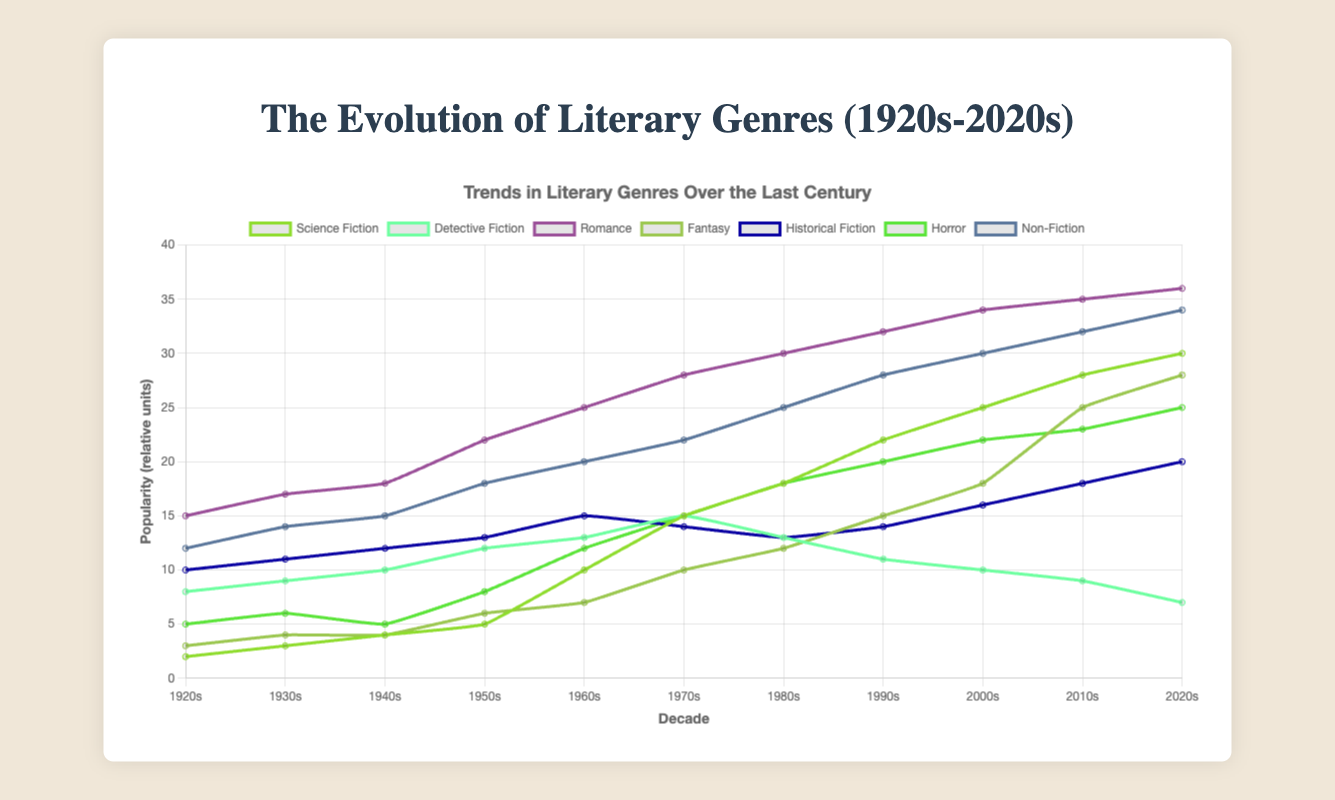Which genre shows the highest increase in popularity from the 1920s to the 2020s? To find out which genre shows the highest increase in popularity from the 1920s to the 2020s, we need to look at the difference in popularity scores between these two decades for each genre. The differences are: Science Fiction (30-2=28), Detective Fiction (7-8=-1), Romance (36-15=21), Fantasy (28-3=25), Historical Fiction (20-10=10), Horror (25-5=20), Non-Fiction (34-12=22). Therefore, Science Fiction shows the highest increase with a change of 28.
Answer: Science Fiction Which genre experienced a decline in popularity from the 1950s to the 2020s? To determine which genre experienced a decline in popularity from the 1950s to the 2020s, we need to compare the popularity scores in these two decades: Science Fiction (5 to 30), Detective Fiction (12 to 7), Romance (22 to 36), Fantasy (6 to 28), Historical Fiction (13 to 20), Horror (8 to 25), Non-Fiction (18 to 34). The only genre with a decline is Detective Fiction, which decreases from 12 to 7.
Answer: Detective Fiction What is the average popularity of the Romance genre from the 1920s to the 2020s? We calculate the average popularity of the Romance genre by summing its values and dividing by the number of decades: (15 + 17 + 18 + 22 + 25 + 28 + 30 + 32 + 34 + 35 + 36) / 11 = 292 / 11 ≈ 26.55.
Answer: 26.55 Which decades saw an equal popularity for Fantasy and Historical Fiction? To find decades with equal popularity between Fantasy and Historical Fiction, we compare their scores for each decade: For the 1920s (Fantasy 3, Historical Fiction 10), 1930s (4, 11), 1940s (4, 12), 1950s (6, 13), 1960s (7, 15), 1970s (10, 14), 1980s (12, 13), 1990s (15, 14), 2000s (18, 16), 2010s (25, 18), 2020s (28, 20). No decades have equal popularity.
Answer: None How many genres surpassed the 20 popularity mark by the 2010s? We look at the popularity scores of each genre for the 2010s: Science Fiction (28), Detective Fiction (9), Romance (35), Fantasy (25), Historical Fiction (18), Horror (23), Non-Fiction (32). The genres surpassing 20 are: Science Fiction, Romance, Fantasy, Horror, and Non-Fiction. The total number is 5.
Answer: 5 